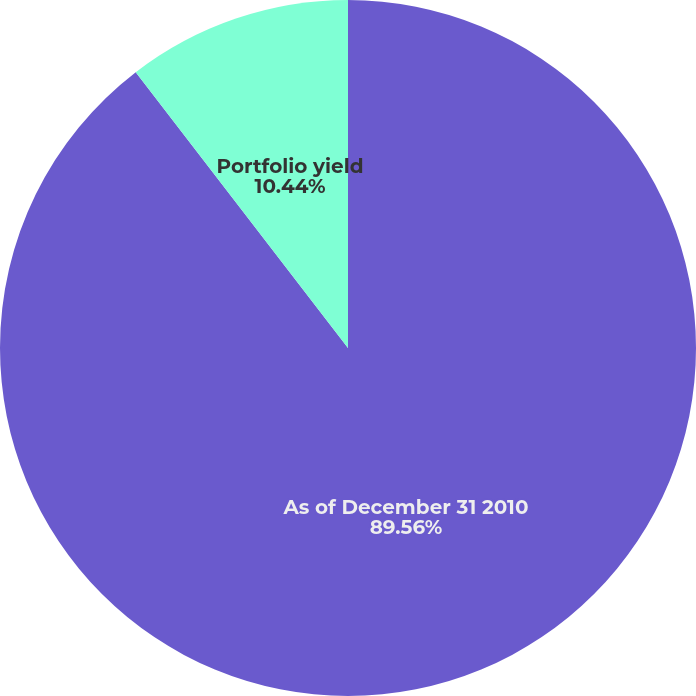<chart> <loc_0><loc_0><loc_500><loc_500><pie_chart><fcel>As of December 31 2010<fcel>Portfolio yield<nl><fcel>89.56%<fcel>10.44%<nl></chart> 